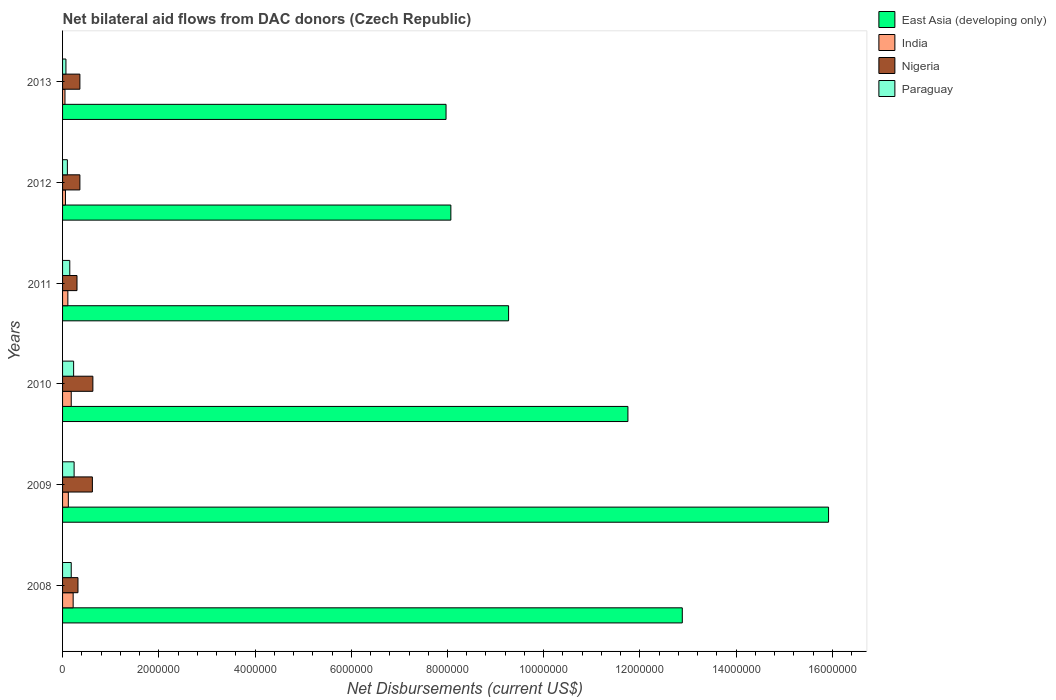Are the number of bars on each tick of the Y-axis equal?
Offer a terse response. Yes. How many bars are there on the 1st tick from the bottom?
Make the answer very short. 4. What is the net bilateral aid flows in India in 2010?
Your answer should be compact. 1.80e+05. Across all years, what is the maximum net bilateral aid flows in India?
Give a very brief answer. 2.20e+05. Across all years, what is the minimum net bilateral aid flows in Nigeria?
Give a very brief answer. 3.00e+05. In which year was the net bilateral aid flows in East Asia (developing only) minimum?
Your response must be concise. 2013. What is the total net bilateral aid flows in India in the graph?
Your answer should be very brief. 7.40e+05. What is the difference between the net bilateral aid flows in East Asia (developing only) in 2009 and that in 2011?
Give a very brief answer. 6.65e+06. What is the difference between the net bilateral aid flows in Nigeria in 2010 and the net bilateral aid flows in India in 2008?
Provide a short and direct response. 4.10e+05. What is the average net bilateral aid flows in Paraguay per year?
Keep it short and to the point. 1.62e+05. In the year 2012, what is the difference between the net bilateral aid flows in Paraguay and net bilateral aid flows in East Asia (developing only)?
Keep it short and to the point. -7.97e+06. In how many years, is the net bilateral aid flows in East Asia (developing only) greater than 7200000 US$?
Make the answer very short. 6. What is the ratio of the net bilateral aid flows in Paraguay in 2009 to that in 2011?
Keep it short and to the point. 1.6. Is the difference between the net bilateral aid flows in Paraguay in 2009 and 2013 greater than the difference between the net bilateral aid flows in East Asia (developing only) in 2009 and 2013?
Your response must be concise. No. What is the difference between the highest and the second highest net bilateral aid flows in East Asia (developing only)?
Offer a terse response. 3.04e+06. What is the difference between the highest and the lowest net bilateral aid flows in Paraguay?
Provide a short and direct response. 1.70e+05. In how many years, is the net bilateral aid flows in Nigeria greater than the average net bilateral aid flows in Nigeria taken over all years?
Make the answer very short. 2. Is the sum of the net bilateral aid flows in Paraguay in 2012 and 2013 greater than the maximum net bilateral aid flows in East Asia (developing only) across all years?
Make the answer very short. No. What does the 1st bar from the top in 2012 represents?
Give a very brief answer. Paraguay. What does the 4th bar from the bottom in 2009 represents?
Keep it short and to the point. Paraguay. Is it the case that in every year, the sum of the net bilateral aid flows in India and net bilateral aid flows in East Asia (developing only) is greater than the net bilateral aid flows in Paraguay?
Give a very brief answer. Yes. Are all the bars in the graph horizontal?
Keep it short and to the point. Yes. What is the difference between two consecutive major ticks on the X-axis?
Provide a succinct answer. 2.00e+06. Are the values on the major ticks of X-axis written in scientific E-notation?
Ensure brevity in your answer.  No. Does the graph contain any zero values?
Offer a very short reply. No. Does the graph contain grids?
Provide a short and direct response. No. How many legend labels are there?
Make the answer very short. 4. What is the title of the graph?
Offer a very short reply. Net bilateral aid flows from DAC donors (Czech Republic). What is the label or title of the X-axis?
Ensure brevity in your answer.  Net Disbursements (current US$). What is the label or title of the Y-axis?
Your response must be concise. Years. What is the Net Disbursements (current US$) of East Asia (developing only) in 2008?
Your answer should be compact. 1.29e+07. What is the Net Disbursements (current US$) of India in 2008?
Your answer should be compact. 2.20e+05. What is the Net Disbursements (current US$) in Nigeria in 2008?
Offer a very short reply. 3.20e+05. What is the Net Disbursements (current US$) in Paraguay in 2008?
Offer a very short reply. 1.80e+05. What is the Net Disbursements (current US$) of East Asia (developing only) in 2009?
Your answer should be compact. 1.59e+07. What is the Net Disbursements (current US$) in Nigeria in 2009?
Offer a very short reply. 6.20e+05. What is the Net Disbursements (current US$) in Paraguay in 2009?
Keep it short and to the point. 2.40e+05. What is the Net Disbursements (current US$) in East Asia (developing only) in 2010?
Keep it short and to the point. 1.18e+07. What is the Net Disbursements (current US$) in India in 2010?
Ensure brevity in your answer.  1.80e+05. What is the Net Disbursements (current US$) of Nigeria in 2010?
Offer a terse response. 6.30e+05. What is the Net Disbursements (current US$) of East Asia (developing only) in 2011?
Your response must be concise. 9.27e+06. What is the Net Disbursements (current US$) of India in 2011?
Give a very brief answer. 1.10e+05. What is the Net Disbursements (current US$) of Nigeria in 2011?
Make the answer very short. 3.00e+05. What is the Net Disbursements (current US$) in East Asia (developing only) in 2012?
Provide a succinct answer. 8.07e+06. What is the Net Disbursements (current US$) of India in 2012?
Offer a terse response. 6.00e+04. What is the Net Disbursements (current US$) in Nigeria in 2012?
Your answer should be compact. 3.60e+05. What is the Net Disbursements (current US$) in Paraguay in 2012?
Provide a short and direct response. 1.00e+05. What is the Net Disbursements (current US$) of East Asia (developing only) in 2013?
Provide a succinct answer. 7.97e+06. What is the Net Disbursements (current US$) of Nigeria in 2013?
Make the answer very short. 3.60e+05. What is the Net Disbursements (current US$) in Paraguay in 2013?
Give a very brief answer. 7.00e+04. Across all years, what is the maximum Net Disbursements (current US$) of East Asia (developing only)?
Give a very brief answer. 1.59e+07. Across all years, what is the maximum Net Disbursements (current US$) in Nigeria?
Provide a short and direct response. 6.30e+05. Across all years, what is the minimum Net Disbursements (current US$) of East Asia (developing only)?
Your response must be concise. 7.97e+06. Across all years, what is the minimum Net Disbursements (current US$) in Paraguay?
Offer a terse response. 7.00e+04. What is the total Net Disbursements (current US$) in East Asia (developing only) in the graph?
Your response must be concise. 6.59e+07. What is the total Net Disbursements (current US$) of India in the graph?
Your answer should be compact. 7.40e+05. What is the total Net Disbursements (current US$) of Nigeria in the graph?
Ensure brevity in your answer.  2.59e+06. What is the total Net Disbursements (current US$) in Paraguay in the graph?
Your answer should be very brief. 9.70e+05. What is the difference between the Net Disbursements (current US$) in East Asia (developing only) in 2008 and that in 2009?
Ensure brevity in your answer.  -3.04e+06. What is the difference between the Net Disbursements (current US$) in India in 2008 and that in 2009?
Offer a terse response. 1.00e+05. What is the difference between the Net Disbursements (current US$) in Nigeria in 2008 and that in 2009?
Provide a succinct answer. -3.00e+05. What is the difference between the Net Disbursements (current US$) in East Asia (developing only) in 2008 and that in 2010?
Ensure brevity in your answer.  1.13e+06. What is the difference between the Net Disbursements (current US$) in India in 2008 and that in 2010?
Keep it short and to the point. 4.00e+04. What is the difference between the Net Disbursements (current US$) of Nigeria in 2008 and that in 2010?
Offer a very short reply. -3.10e+05. What is the difference between the Net Disbursements (current US$) in Paraguay in 2008 and that in 2010?
Keep it short and to the point. -5.00e+04. What is the difference between the Net Disbursements (current US$) in East Asia (developing only) in 2008 and that in 2011?
Your answer should be compact. 3.61e+06. What is the difference between the Net Disbursements (current US$) in East Asia (developing only) in 2008 and that in 2012?
Your answer should be very brief. 4.81e+06. What is the difference between the Net Disbursements (current US$) in India in 2008 and that in 2012?
Your answer should be compact. 1.60e+05. What is the difference between the Net Disbursements (current US$) in Nigeria in 2008 and that in 2012?
Provide a short and direct response. -4.00e+04. What is the difference between the Net Disbursements (current US$) in Paraguay in 2008 and that in 2012?
Your answer should be very brief. 8.00e+04. What is the difference between the Net Disbursements (current US$) of East Asia (developing only) in 2008 and that in 2013?
Provide a succinct answer. 4.91e+06. What is the difference between the Net Disbursements (current US$) in India in 2008 and that in 2013?
Your response must be concise. 1.70e+05. What is the difference between the Net Disbursements (current US$) of Nigeria in 2008 and that in 2013?
Make the answer very short. -4.00e+04. What is the difference between the Net Disbursements (current US$) in East Asia (developing only) in 2009 and that in 2010?
Your answer should be very brief. 4.17e+06. What is the difference between the Net Disbursements (current US$) of India in 2009 and that in 2010?
Your response must be concise. -6.00e+04. What is the difference between the Net Disbursements (current US$) of Paraguay in 2009 and that in 2010?
Provide a short and direct response. 10000. What is the difference between the Net Disbursements (current US$) in East Asia (developing only) in 2009 and that in 2011?
Give a very brief answer. 6.65e+06. What is the difference between the Net Disbursements (current US$) in India in 2009 and that in 2011?
Offer a very short reply. 10000. What is the difference between the Net Disbursements (current US$) in Nigeria in 2009 and that in 2011?
Provide a succinct answer. 3.20e+05. What is the difference between the Net Disbursements (current US$) of East Asia (developing only) in 2009 and that in 2012?
Your answer should be very brief. 7.85e+06. What is the difference between the Net Disbursements (current US$) of Nigeria in 2009 and that in 2012?
Offer a terse response. 2.60e+05. What is the difference between the Net Disbursements (current US$) in East Asia (developing only) in 2009 and that in 2013?
Keep it short and to the point. 7.95e+06. What is the difference between the Net Disbursements (current US$) of India in 2009 and that in 2013?
Provide a short and direct response. 7.00e+04. What is the difference between the Net Disbursements (current US$) of Paraguay in 2009 and that in 2013?
Give a very brief answer. 1.70e+05. What is the difference between the Net Disbursements (current US$) in East Asia (developing only) in 2010 and that in 2011?
Your response must be concise. 2.48e+06. What is the difference between the Net Disbursements (current US$) in India in 2010 and that in 2011?
Give a very brief answer. 7.00e+04. What is the difference between the Net Disbursements (current US$) of Nigeria in 2010 and that in 2011?
Your answer should be very brief. 3.30e+05. What is the difference between the Net Disbursements (current US$) in East Asia (developing only) in 2010 and that in 2012?
Offer a very short reply. 3.68e+06. What is the difference between the Net Disbursements (current US$) of India in 2010 and that in 2012?
Offer a terse response. 1.20e+05. What is the difference between the Net Disbursements (current US$) of Nigeria in 2010 and that in 2012?
Offer a very short reply. 2.70e+05. What is the difference between the Net Disbursements (current US$) in East Asia (developing only) in 2010 and that in 2013?
Provide a short and direct response. 3.78e+06. What is the difference between the Net Disbursements (current US$) in East Asia (developing only) in 2011 and that in 2012?
Offer a terse response. 1.20e+06. What is the difference between the Net Disbursements (current US$) of India in 2011 and that in 2012?
Provide a succinct answer. 5.00e+04. What is the difference between the Net Disbursements (current US$) of East Asia (developing only) in 2011 and that in 2013?
Your answer should be very brief. 1.30e+06. What is the difference between the Net Disbursements (current US$) of East Asia (developing only) in 2012 and that in 2013?
Provide a succinct answer. 1.00e+05. What is the difference between the Net Disbursements (current US$) of India in 2012 and that in 2013?
Offer a terse response. 10000. What is the difference between the Net Disbursements (current US$) in Nigeria in 2012 and that in 2013?
Ensure brevity in your answer.  0. What is the difference between the Net Disbursements (current US$) in Paraguay in 2012 and that in 2013?
Your answer should be very brief. 3.00e+04. What is the difference between the Net Disbursements (current US$) in East Asia (developing only) in 2008 and the Net Disbursements (current US$) in India in 2009?
Offer a terse response. 1.28e+07. What is the difference between the Net Disbursements (current US$) of East Asia (developing only) in 2008 and the Net Disbursements (current US$) of Nigeria in 2009?
Give a very brief answer. 1.23e+07. What is the difference between the Net Disbursements (current US$) of East Asia (developing only) in 2008 and the Net Disbursements (current US$) of Paraguay in 2009?
Your answer should be very brief. 1.26e+07. What is the difference between the Net Disbursements (current US$) in India in 2008 and the Net Disbursements (current US$) in Nigeria in 2009?
Ensure brevity in your answer.  -4.00e+05. What is the difference between the Net Disbursements (current US$) of India in 2008 and the Net Disbursements (current US$) of Paraguay in 2009?
Your answer should be very brief. -2.00e+04. What is the difference between the Net Disbursements (current US$) of Nigeria in 2008 and the Net Disbursements (current US$) of Paraguay in 2009?
Give a very brief answer. 8.00e+04. What is the difference between the Net Disbursements (current US$) in East Asia (developing only) in 2008 and the Net Disbursements (current US$) in India in 2010?
Your answer should be compact. 1.27e+07. What is the difference between the Net Disbursements (current US$) in East Asia (developing only) in 2008 and the Net Disbursements (current US$) in Nigeria in 2010?
Make the answer very short. 1.22e+07. What is the difference between the Net Disbursements (current US$) of East Asia (developing only) in 2008 and the Net Disbursements (current US$) of Paraguay in 2010?
Make the answer very short. 1.26e+07. What is the difference between the Net Disbursements (current US$) of India in 2008 and the Net Disbursements (current US$) of Nigeria in 2010?
Offer a terse response. -4.10e+05. What is the difference between the Net Disbursements (current US$) of East Asia (developing only) in 2008 and the Net Disbursements (current US$) of India in 2011?
Ensure brevity in your answer.  1.28e+07. What is the difference between the Net Disbursements (current US$) of East Asia (developing only) in 2008 and the Net Disbursements (current US$) of Nigeria in 2011?
Offer a terse response. 1.26e+07. What is the difference between the Net Disbursements (current US$) of East Asia (developing only) in 2008 and the Net Disbursements (current US$) of Paraguay in 2011?
Offer a very short reply. 1.27e+07. What is the difference between the Net Disbursements (current US$) in India in 2008 and the Net Disbursements (current US$) in Nigeria in 2011?
Provide a short and direct response. -8.00e+04. What is the difference between the Net Disbursements (current US$) of East Asia (developing only) in 2008 and the Net Disbursements (current US$) of India in 2012?
Make the answer very short. 1.28e+07. What is the difference between the Net Disbursements (current US$) of East Asia (developing only) in 2008 and the Net Disbursements (current US$) of Nigeria in 2012?
Provide a short and direct response. 1.25e+07. What is the difference between the Net Disbursements (current US$) of East Asia (developing only) in 2008 and the Net Disbursements (current US$) of Paraguay in 2012?
Offer a terse response. 1.28e+07. What is the difference between the Net Disbursements (current US$) in India in 2008 and the Net Disbursements (current US$) in Nigeria in 2012?
Your response must be concise. -1.40e+05. What is the difference between the Net Disbursements (current US$) of East Asia (developing only) in 2008 and the Net Disbursements (current US$) of India in 2013?
Give a very brief answer. 1.28e+07. What is the difference between the Net Disbursements (current US$) of East Asia (developing only) in 2008 and the Net Disbursements (current US$) of Nigeria in 2013?
Provide a succinct answer. 1.25e+07. What is the difference between the Net Disbursements (current US$) of East Asia (developing only) in 2008 and the Net Disbursements (current US$) of Paraguay in 2013?
Provide a short and direct response. 1.28e+07. What is the difference between the Net Disbursements (current US$) in India in 2008 and the Net Disbursements (current US$) in Nigeria in 2013?
Give a very brief answer. -1.40e+05. What is the difference between the Net Disbursements (current US$) in East Asia (developing only) in 2009 and the Net Disbursements (current US$) in India in 2010?
Offer a very short reply. 1.57e+07. What is the difference between the Net Disbursements (current US$) of East Asia (developing only) in 2009 and the Net Disbursements (current US$) of Nigeria in 2010?
Your response must be concise. 1.53e+07. What is the difference between the Net Disbursements (current US$) in East Asia (developing only) in 2009 and the Net Disbursements (current US$) in Paraguay in 2010?
Offer a very short reply. 1.57e+07. What is the difference between the Net Disbursements (current US$) of India in 2009 and the Net Disbursements (current US$) of Nigeria in 2010?
Keep it short and to the point. -5.10e+05. What is the difference between the Net Disbursements (current US$) in India in 2009 and the Net Disbursements (current US$) in Paraguay in 2010?
Ensure brevity in your answer.  -1.10e+05. What is the difference between the Net Disbursements (current US$) in Nigeria in 2009 and the Net Disbursements (current US$) in Paraguay in 2010?
Your answer should be compact. 3.90e+05. What is the difference between the Net Disbursements (current US$) of East Asia (developing only) in 2009 and the Net Disbursements (current US$) of India in 2011?
Keep it short and to the point. 1.58e+07. What is the difference between the Net Disbursements (current US$) of East Asia (developing only) in 2009 and the Net Disbursements (current US$) of Nigeria in 2011?
Provide a short and direct response. 1.56e+07. What is the difference between the Net Disbursements (current US$) in East Asia (developing only) in 2009 and the Net Disbursements (current US$) in Paraguay in 2011?
Your answer should be very brief. 1.58e+07. What is the difference between the Net Disbursements (current US$) in India in 2009 and the Net Disbursements (current US$) in Nigeria in 2011?
Make the answer very short. -1.80e+05. What is the difference between the Net Disbursements (current US$) of India in 2009 and the Net Disbursements (current US$) of Paraguay in 2011?
Offer a very short reply. -3.00e+04. What is the difference between the Net Disbursements (current US$) in East Asia (developing only) in 2009 and the Net Disbursements (current US$) in India in 2012?
Your response must be concise. 1.59e+07. What is the difference between the Net Disbursements (current US$) of East Asia (developing only) in 2009 and the Net Disbursements (current US$) of Nigeria in 2012?
Offer a terse response. 1.56e+07. What is the difference between the Net Disbursements (current US$) in East Asia (developing only) in 2009 and the Net Disbursements (current US$) in Paraguay in 2012?
Offer a terse response. 1.58e+07. What is the difference between the Net Disbursements (current US$) of India in 2009 and the Net Disbursements (current US$) of Nigeria in 2012?
Your answer should be compact. -2.40e+05. What is the difference between the Net Disbursements (current US$) in Nigeria in 2009 and the Net Disbursements (current US$) in Paraguay in 2012?
Offer a very short reply. 5.20e+05. What is the difference between the Net Disbursements (current US$) of East Asia (developing only) in 2009 and the Net Disbursements (current US$) of India in 2013?
Offer a very short reply. 1.59e+07. What is the difference between the Net Disbursements (current US$) of East Asia (developing only) in 2009 and the Net Disbursements (current US$) of Nigeria in 2013?
Your answer should be compact. 1.56e+07. What is the difference between the Net Disbursements (current US$) of East Asia (developing only) in 2009 and the Net Disbursements (current US$) of Paraguay in 2013?
Make the answer very short. 1.58e+07. What is the difference between the Net Disbursements (current US$) in India in 2009 and the Net Disbursements (current US$) in Nigeria in 2013?
Provide a short and direct response. -2.40e+05. What is the difference between the Net Disbursements (current US$) of India in 2009 and the Net Disbursements (current US$) of Paraguay in 2013?
Keep it short and to the point. 5.00e+04. What is the difference between the Net Disbursements (current US$) in Nigeria in 2009 and the Net Disbursements (current US$) in Paraguay in 2013?
Keep it short and to the point. 5.50e+05. What is the difference between the Net Disbursements (current US$) in East Asia (developing only) in 2010 and the Net Disbursements (current US$) in India in 2011?
Offer a terse response. 1.16e+07. What is the difference between the Net Disbursements (current US$) of East Asia (developing only) in 2010 and the Net Disbursements (current US$) of Nigeria in 2011?
Make the answer very short. 1.14e+07. What is the difference between the Net Disbursements (current US$) in East Asia (developing only) in 2010 and the Net Disbursements (current US$) in Paraguay in 2011?
Your answer should be very brief. 1.16e+07. What is the difference between the Net Disbursements (current US$) of India in 2010 and the Net Disbursements (current US$) of Paraguay in 2011?
Your answer should be very brief. 3.00e+04. What is the difference between the Net Disbursements (current US$) of East Asia (developing only) in 2010 and the Net Disbursements (current US$) of India in 2012?
Your answer should be compact. 1.17e+07. What is the difference between the Net Disbursements (current US$) of East Asia (developing only) in 2010 and the Net Disbursements (current US$) of Nigeria in 2012?
Give a very brief answer. 1.14e+07. What is the difference between the Net Disbursements (current US$) of East Asia (developing only) in 2010 and the Net Disbursements (current US$) of Paraguay in 2012?
Keep it short and to the point. 1.16e+07. What is the difference between the Net Disbursements (current US$) of India in 2010 and the Net Disbursements (current US$) of Paraguay in 2012?
Make the answer very short. 8.00e+04. What is the difference between the Net Disbursements (current US$) in Nigeria in 2010 and the Net Disbursements (current US$) in Paraguay in 2012?
Offer a terse response. 5.30e+05. What is the difference between the Net Disbursements (current US$) in East Asia (developing only) in 2010 and the Net Disbursements (current US$) in India in 2013?
Ensure brevity in your answer.  1.17e+07. What is the difference between the Net Disbursements (current US$) of East Asia (developing only) in 2010 and the Net Disbursements (current US$) of Nigeria in 2013?
Ensure brevity in your answer.  1.14e+07. What is the difference between the Net Disbursements (current US$) of East Asia (developing only) in 2010 and the Net Disbursements (current US$) of Paraguay in 2013?
Offer a terse response. 1.17e+07. What is the difference between the Net Disbursements (current US$) in India in 2010 and the Net Disbursements (current US$) in Nigeria in 2013?
Provide a succinct answer. -1.80e+05. What is the difference between the Net Disbursements (current US$) of Nigeria in 2010 and the Net Disbursements (current US$) of Paraguay in 2013?
Provide a succinct answer. 5.60e+05. What is the difference between the Net Disbursements (current US$) of East Asia (developing only) in 2011 and the Net Disbursements (current US$) of India in 2012?
Offer a terse response. 9.21e+06. What is the difference between the Net Disbursements (current US$) in East Asia (developing only) in 2011 and the Net Disbursements (current US$) in Nigeria in 2012?
Give a very brief answer. 8.91e+06. What is the difference between the Net Disbursements (current US$) in East Asia (developing only) in 2011 and the Net Disbursements (current US$) in Paraguay in 2012?
Provide a succinct answer. 9.17e+06. What is the difference between the Net Disbursements (current US$) in India in 2011 and the Net Disbursements (current US$) in Nigeria in 2012?
Make the answer very short. -2.50e+05. What is the difference between the Net Disbursements (current US$) in East Asia (developing only) in 2011 and the Net Disbursements (current US$) in India in 2013?
Make the answer very short. 9.22e+06. What is the difference between the Net Disbursements (current US$) in East Asia (developing only) in 2011 and the Net Disbursements (current US$) in Nigeria in 2013?
Your answer should be very brief. 8.91e+06. What is the difference between the Net Disbursements (current US$) of East Asia (developing only) in 2011 and the Net Disbursements (current US$) of Paraguay in 2013?
Offer a very short reply. 9.20e+06. What is the difference between the Net Disbursements (current US$) of India in 2011 and the Net Disbursements (current US$) of Nigeria in 2013?
Offer a terse response. -2.50e+05. What is the difference between the Net Disbursements (current US$) in East Asia (developing only) in 2012 and the Net Disbursements (current US$) in India in 2013?
Provide a succinct answer. 8.02e+06. What is the difference between the Net Disbursements (current US$) of East Asia (developing only) in 2012 and the Net Disbursements (current US$) of Nigeria in 2013?
Offer a terse response. 7.71e+06. What is the difference between the Net Disbursements (current US$) of East Asia (developing only) in 2012 and the Net Disbursements (current US$) of Paraguay in 2013?
Give a very brief answer. 8.00e+06. What is the difference between the Net Disbursements (current US$) of India in 2012 and the Net Disbursements (current US$) of Nigeria in 2013?
Offer a terse response. -3.00e+05. What is the average Net Disbursements (current US$) in East Asia (developing only) per year?
Make the answer very short. 1.10e+07. What is the average Net Disbursements (current US$) of India per year?
Ensure brevity in your answer.  1.23e+05. What is the average Net Disbursements (current US$) of Nigeria per year?
Your response must be concise. 4.32e+05. What is the average Net Disbursements (current US$) in Paraguay per year?
Your response must be concise. 1.62e+05. In the year 2008, what is the difference between the Net Disbursements (current US$) in East Asia (developing only) and Net Disbursements (current US$) in India?
Provide a short and direct response. 1.27e+07. In the year 2008, what is the difference between the Net Disbursements (current US$) in East Asia (developing only) and Net Disbursements (current US$) in Nigeria?
Provide a short and direct response. 1.26e+07. In the year 2008, what is the difference between the Net Disbursements (current US$) of East Asia (developing only) and Net Disbursements (current US$) of Paraguay?
Offer a terse response. 1.27e+07. In the year 2008, what is the difference between the Net Disbursements (current US$) of India and Net Disbursements (current US$) of Nigeria?
Give a very brief answer. -1.00e+05. In the year 2008, what is the difference between the Net Disbursements (current US$) in India and Net Disbursements (current US$) in Paraguay?
Your response must be concise. 4.00e+04. In the year 2008, what is the difference between the Net Disbursements (current US$) of Nigeria and Net Disbursements (current US$) of Paraguay?
Keep it short and to the point. 1.40e+05. In the year 2009, what is the difference between the Net Disbursements (current US$) in East Asia (developing only) and Net Disbursements (current US$) in India?
Make the answer very short. 1.58e+07. In the year 2009, what is the difference between the Net Disbursements (current US$) in East Asia (developing only) and Net Disbursements (current US$) in Nigeria?
Your answer should be very brief. 1.53e+07. In the year 2009, what is the difference between the Net Disbursements (current US$) in East Asia (developing only) and Net Disbursements (current US$) in Paraguay?
Keep it short and to the point. 1.57e+07. In the year 2009, what is the difference between the Net Disbursements (current US$) in India and Net Disbursements (current US$) in Nigeria?
Ensure brevity in your answer.  -5.00e+05. In the year 2009, what is the difference between the Net Disbursements (current US$) of India and Net Disbursements (current US$) of Paraguay?
Your answer should be compact. -1.20e+05. In the year 2010, what is the difference between the Net Disbursements (current US$) of East Asia (developing only) and Net Disbursements (current US$) of India?
Ensure brevity in your answer.  1.16e+07. In the year 2010, what is the difference between the Net Disbursements (current US$) of East Asia (developing only) and Net Disbursements (current US$) of Nigeria?
Provide a short and direct response. 1.11e+07. In the year 2010, what is the difference between the Net Disbursements (current US$) in East Asia (developing only) and Net Disbursements (current US$) in Paraguay?
Provide a succinct answer. 1.15e+07. In the year 2010, what is the difference between the Net Disbursements (current US$) in India and Net Disbursements (current US$) in Nigeria?
Make the answer very short. -4.50e+05. In the year 2010, what is the difference between the Net Disbursements (current US$) of India and Net Disbursements (current US$) of Paraguay?
Your answer should be compact. -5.00e+04. In the year 2011, what is the difference between the Net Disbursements (current US$) of East Asia (developing only) and Net Disbursements (current US$) of India?
Keep it short and to the point. 9.16e+06. In the year 2011, what is the difference between the Net Disbursements (current US$) in East Asia (developing only) and Net Disbursements (current US$) in Nigeria?
Make the answer very short. 8.97e+06. In the year 2011, what is the difference between the Net Disbursements (current US$) of East Asia (developing only) and Net Disbursements (current US$) of Paraguay?
Your answer should be very brief. 9.12e+06. In the year 2011, what is the difference between the Net Disbursements (current US$) of India and Net Disbursements (current US$) of Nigeria?
Your response must be concise. -1.90e+05. In the year 2011, what is the difference between the Net Disbursements (current US$) of India and Net Disbursements (current US$) of Paraguay?
Provide a short and direct response. -4.00e+04. In the year 2011, what is the difference between the Net Disbursements (current US$) of Nigeria and Net Disbursements (current US$) of Paraguay?
Ensure brevity in your answer.  1.50e+05. In the year 2012, what is the difference between the Net Disbursements (current US$) of East Asia (developing only) and Net Disbursements (current US$) of India?
Provide a short and direct response. 8.01e+06. In the year 2012, what is the difference between the Net Disbursements (current US$) in East Asia (developing only) and Net Disbursements (current US$) in Nigeria?
Give a very brief answer. 7.71e+06. In the year 2012, what is the difference between the Net Disbursements (current US$) of East Asia (developing only) and Net Disbursements (current US$) of Paraguay?
Provide a succinct answer. 7.97e+06. In the year 2013, what is the difference between the Net Disbursements (current US$) in East Asia (developing only) and Net Disbursements (current US$) in India?
Give a very brief answer. 7.92e+06. In the year 2013, what is the difference between the Net Disbursements (current US$) in East Asia (developing only) and Net Disbursements (current US$) in Nigeria?
Offer a very short reply. 7.61e+06. In the year 2013, what is the difference between the Net Disbursements (current US$) in East Asia (developing only) and Net Disbursements (current US$) in Paraguay?
Offer a terse response. 7.90e+06. In the year 2013, what is the difference between the Net Disbursements (current US$) in India and Net Disbursements (current US$) in Nigeria?
Your answer should be very brief. -3.10e+05. In the year 2013, what is the difference between the Net Disbursements (current US$) of India and Net Disbursements (current US$) of Paraguay?
Provide a short and direct response. -2.00e+04. What is the ratio of the Net Disbursements (current US$) of East Asia (developing only) in 2008 to that in 2009?
Keep it short and to the point. 0.81. What is the ratio of the Net Disbursements (current US$) in India in 2008 to that in 2009?
Your response must be concise. 1.83. What is the ratio of the Net Disbursements (current US$) in Nigeria in 2008 to that in 2009?
Make the answer very short. 0.52. What is the ratio of the Net Disbursements (current US$) in East Asia (developing only) in 2008 to that in 2010?
Provide a succinct answer. 1.1. What is the ratio of the Net Disbursements (current US$) in India in 2008 to that in 2010?
Your response must be concise. 1.22. What is the ratio of the Net Disbursements (current US$) in Nigeria in 2008 to that in 2010?
Your response must be concise. 0.51. What is the ratio of the Net Disbursements (current US$) of Paraguay in 2008 to that in 2010?
Your answer should be very brief. 0.78. What is the ratio of the Net Disbursements (current US$) of East Asia (developing only) in 2008 to that in 2011?
Make the answer very short. 1.39. What is the ratio of the Net Disbursements (current US$) in India in 2008 to that in 2011?
Your answer should be compact. 2. What is the ratio of the Net Disbursements (current US$) in Nigeria in 2008 to that in 2011?
Provide a succinct answer. 1.07. What is the ratio of the Net Disbursements (current US$) of Paraguay in 2008 to that in 2011?
Your answer should be compact. 1.2. What is the ratio of the Net Disbursements (current US$) of East Asia (developing only) in 2008 to that in 2012?
Your response must be concise. 1.6. What is the ratio of the Net Disbursements (current US$) of India in 2008 to that in 2012?
Your answer should be very brief. 3.67. What is the ratio of the Net Disbursements (current US$) of Nigeria in 2008 to that in 2012?
Your answer should be compact. 0.89. What is the ratio of the Net Disbursements (current US$) in Paraguay in 2008 to that in 2012?
Provide a succinct answer. 1.8. What is the ratio of the Net Disbursements (current US$) of East Asia (developing only) in 2008 to that in 2013?
Provide a short and direct response. 1.62. What is the ratio of the Net Disbursements (current US$) in Nigeria in 2008 to that in 2013?
Make the answer very short. 0.89. What is the ratio of the Net Disbursements (current US$) of Paraguay in 2008 to that in 2013?
Ensure brevity in your answer.  2.57. What is the ratio of the Net Disbursements (current US$) in East Asia (developing only) in 2009 to that in 2010?
Ensure brevity in your answer.  1.35. What is the ratio of the Net Disbursements (current US$) of India in 2009 to that in 2010?
Offer a terse response. 0.67. What is the ratio of the Net Disbursements (current US$) in Nigeria in 2009 to that in 2010?
Offer a terse response. 0.98. What is the ratio of the Net Disbursements (current US$) of Paraguay in 2009 to that in 2010?
Provide a short and direct response. 1.04. What is the ratio of the Net Disbursements (current US$) in East Asia (developing only) in 2009 to that in 2011?
Ensure brevity in your answer.  1.72. What is the ratio of the Net Disbursements (current US$) of India in 2009 to that in 2011?
Ensure brevity in your answer.  1.09. What is the ratio of the Net Disbursements (current US$) of Nigeria in 2009 to that in 2011?
Provide a short and direct response. 2.07. What is the ratio of the Net Disbursements (current US$) in East Asia (developing only) in 2009 to that in 2012?
Keep it short and to the point. 1.97. What is the ratio of the Net Disbursements (current US$) in Nigeria in 2009 to that in 2012?
Your answer should be very brief. 1.72. What is the ratio of the Net Disbursements (current US$) of Paraguay in 2009 to that in 2012?
Provide a succinct answer. 2.4. What is the ratio of the Net Disbursements (current US$) in East Asia (developing only) in 2009 to that in 2013?
Your answer should be compact. 2. What is the ratio of the Net Disbursements (current US$) of Nigeria in 2009 to that in 2013?
Offer a terse response. 1.72. What is the ratio of the Net Disbursements (current US$) in Paraguay in 2009 to that in 2013?
Ensure brevity in your answer.  3.43. What is the ratio of the Net Disbursements (current US$) of East Asia (developing only) in 2010 to that in 2011?
Make the answer very short. 1.27. What is the ratio of the Net Disbursements (current US$) of India in 2010 to that in 2011?
Give a very brief answer. 1.64. What is the ratio of the Net Disbursements (current US$) in Nigeria in 2010 to that in 2011?
Your response must be concise. 2.1. What is the ratio of the Net Disbursements (current US$) of Paraguay in 2010 to that in 2011?
Your response must be concise. 1.53. What is the ratio of the Net Disbursements (current US$) of East Asia (developing only) in 2010 to that in 2012?
Provide a short and direct response. 1.46. What is the ratio of the Net Disbursements (current US$) in India in 2010 to that in 2012?
Make the answer very short. 3. What is the ratio of the Net Disbursements (current US$) of Nigeria in 2010 to that in 2012?
Give a very brief answer. 1.75. What is the ratio of the Net Disbursements (current US$) in East Asia (developing only) in 2010 to that in 2013?
Your response must be concise. 1.47. What is the ratio of the Net Disbursements (current US$) in Nigeria in 2010 to that in 2013?
Your response must be concise. 1.75. What is the ratio of the Net Disbursements (current US$) of Paraguay in 2010 to that in 2013?
Provide a succinct answer. 3.29. What is the ratio of the Net Disbursements (current US$) in East Asia (developing only) in 2011 to that in 2012?
Offer a terse response. 1.15. What is the ratio of the Net Disbursements (current US$) in India in 2011 to that in 2012?
Offer a terse response. 1.83. What is the ratio of the Net Disbursements (current US$) in Nigeria in 2011 to that in 2012?
Ensure brevity in your answer.  0.83. What is the ratio of the Net Disbursements (current US$) in Paraguay in 2011 to that in 2012?
Provide a short and direct response. 1.5. What is the ratio of the Net Disbursements (current US$) in East Asia (developing only) in 2011 to that in 2013?
Make the answer very short. 1.16. What is the ratio of the Net Disbursements (current US$) in Paraguay in 2011 to that in 2013?
Keep it short and to the point. 2.14. What is the ratio of the Net Disbursements (current US$) of East Asia (developing only) in 2012 to that in 2013?
Provide a succinct answer. 1.01. What is the ratio of the Net Disbursements (current US$) in Paraguay in 2012 to that in 2013?
Ensure brevity in your answer.  1.43. What is the difference between the highest and the second highest Net Disbursements (current US$) in East Asia (developing only)?
Offer a terse response. 3.04e+06. What is the difference between the highest and the second highest Net Disbursements (current US$) in Nigeria?
Provide a succinct answer. 10000. What is the difference between the highest and the second highest Net Disbursements (current US$) in Paraguay?
Provide a succinct answer. 10000. What is the difference between the highest and the lowest Net Disbursements (current US$) of East Asia (developing only)?
Your response must be concise. 7.95e+06. What is the difference between the highest and the lowest Net Disbursements (current US$) in Paraguay?
Offer a very short reply. 1.70e+05. 